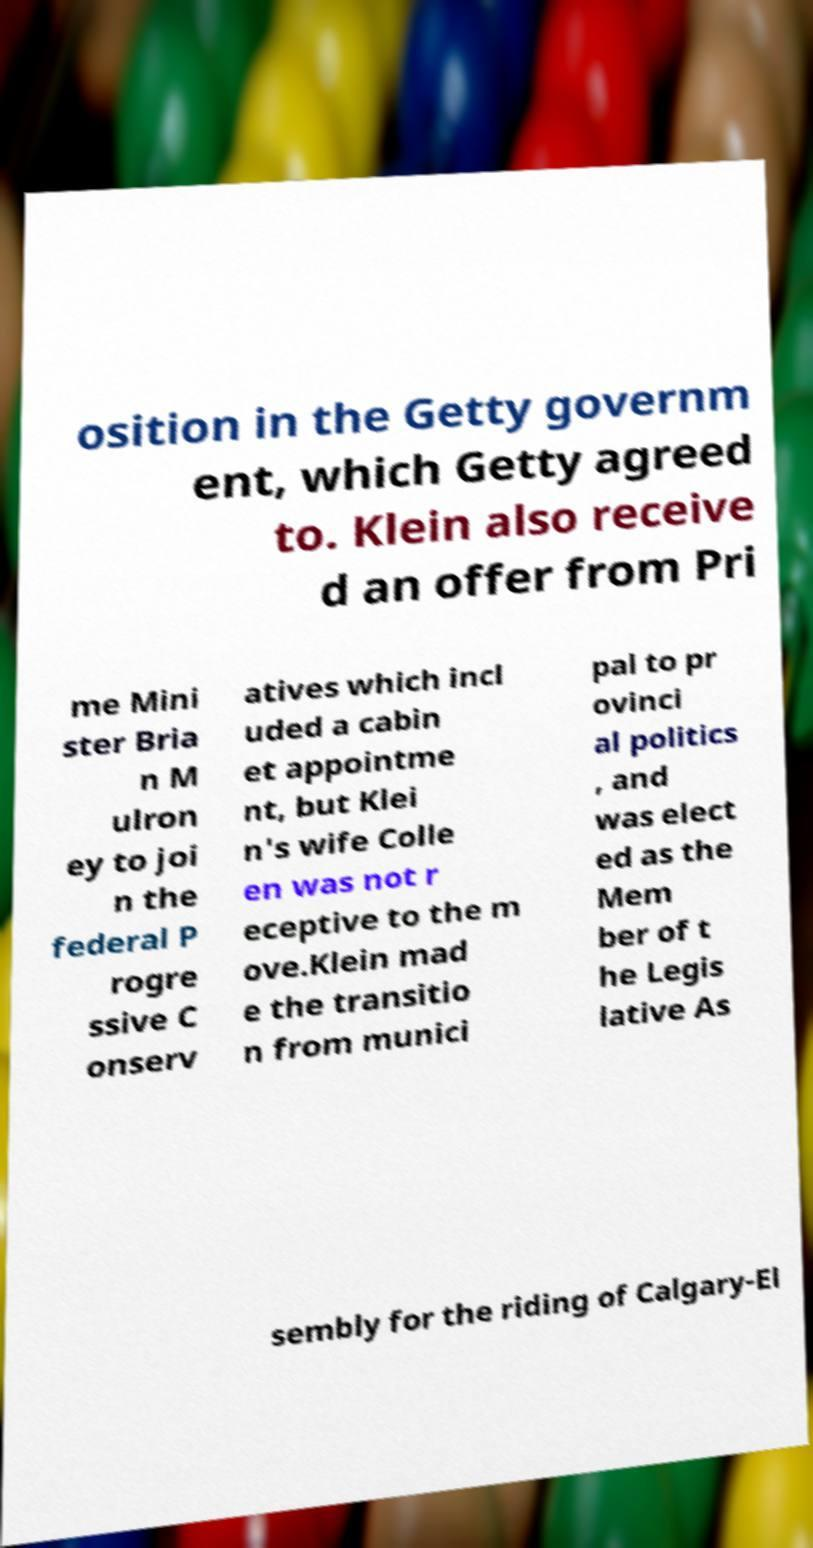What messages or text are displayed in this image? I need them in a readable, typed format. osition in the Getty governm ent, which Getty agreed to. Klein also receive d an offer from Pri me Mini ster Bria n M ulron ey to joi n the federal P rogre ssive C onserv atives which incl uded a cabin et appointme nt, but Klei n's wife Colle en was not r eceptive to the m ove.Klein mad e the transitio n from munici pal to pr ovinci al politics , and was elect ed as the Mem ber of t he Legis lative As sembly for the riding of Calgary-El 